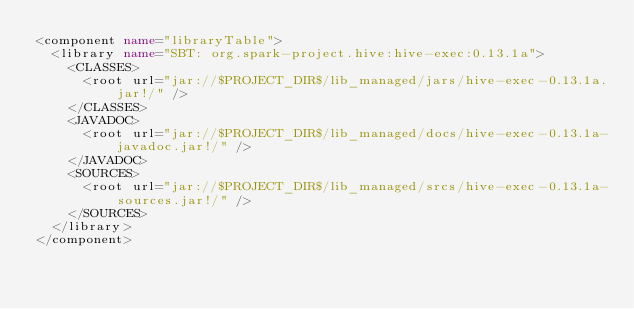Convert code to text. <code><loc_0><loc_0><loc_500><loc_500><_XML_><component name="libraryTable">
  <library name="SBT: org.spark-project.hive:hive-exec:0.13.1a">
    <CLASSES>
      <root url="jar://$PROJECT_DIR$/lib_managed/jars/hive-exec-0.13.1a.jar!/" />
    </CLASSES>
    <JAVADOC>
      <root url="jar://$PROJECT_DIR$/lib_managed/docs/hive-exec-0.13.1a-javadoc.jar!/" />
    </JAVADOC>
    <SOURCES>
      <root url="jar://$PROJECT_DIR$/lib_managed/srcs/hive-exec-0.13.1a-sources.jar!/" />
    </SOURCES>
  </library>
</component></code> 